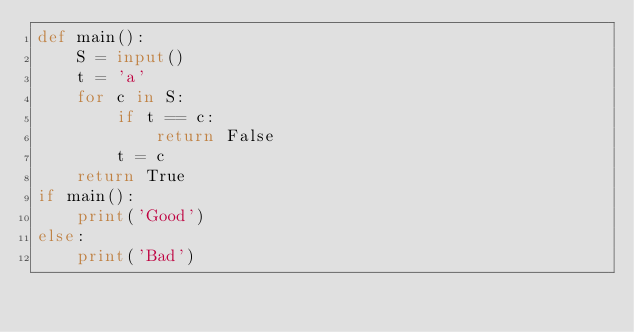<code> <loc_0><loc_0><loc_500><loc_500><_Python_>def main():
    S = input()
    t = 'a'
    for c in S:
        if t == c:
            return False
        t = c
    return True
if main():
    print('Good')
else:
    print('Bad')
</code> 